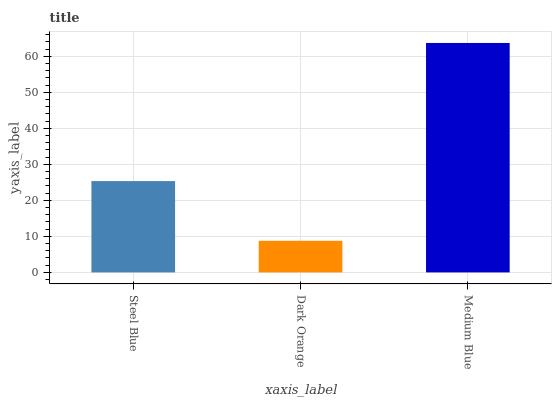Is Medium Blue the minimum?
Answer yes or no. No. Is Dark Orange the maximum?
Answer yes or no. No. Is Medium Blue greater than Dark Orange?
Answer yes or no. Yes. Is Dark Orange less than Medium Blue?
Answer yes or no. Yes. Is Dark Orange greater than Medium Blue?
Answer yes or no. No. Is Medium Blue less than Dark Orange?
Answer yes or no. No. Is Steel Blue the high median?
Answer yes or no. Yes. Is Steel Blue the low median?
Answer yes or no. Yes. Is Dark Orange the high median?
Answer yes or no. No. Is Dark Orange the low median?
Answer yes or no. No. 